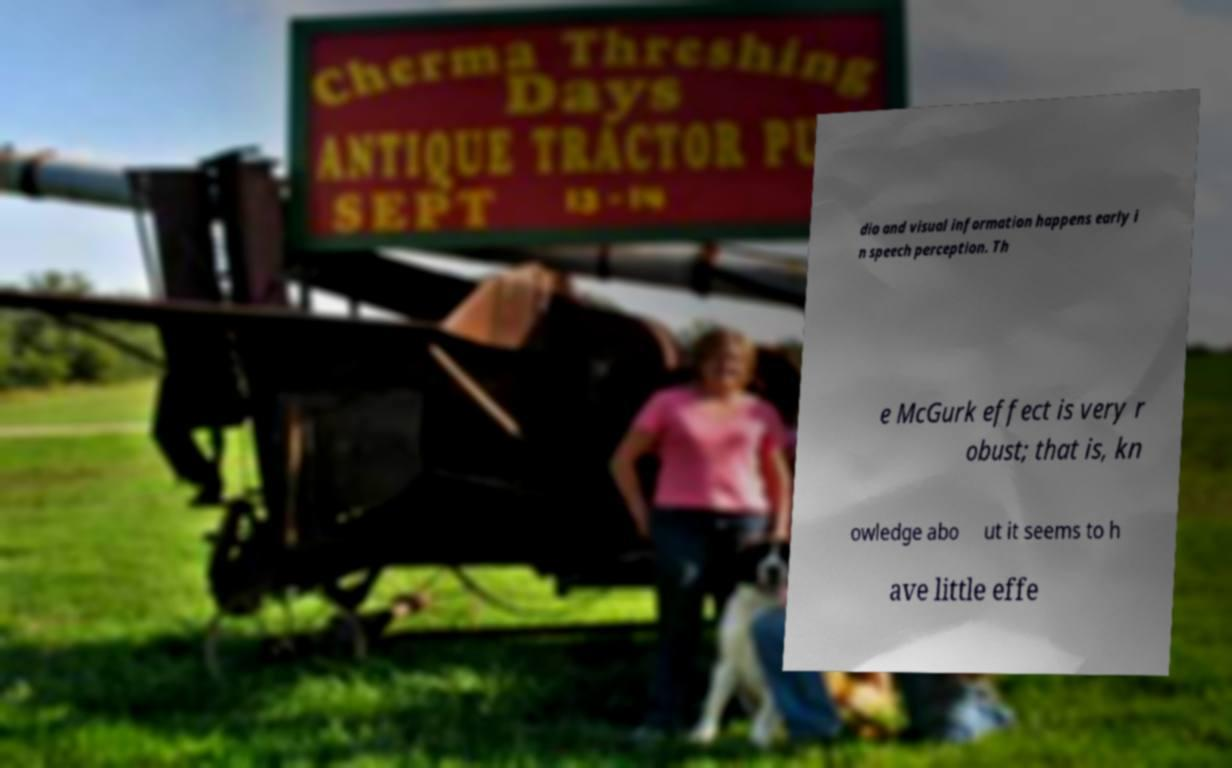What messages or text are displayed in this image? I need them in a readable, typed format. dio and visual information happens early i n speech perception. Th e McGurk effect is very r obust; that is, kn owledge abo ut it seems to h ave little effe 